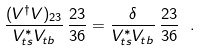Convert formula to latex. <formula><loc_0><loc_0><loc_500><loc_500>\frac { ( V ^ { \dagger } V ) _ { 2 3 } } { V _ { t s } ^ { * } V _ { t b } } \, \frac { 2 3 } { 3 6 } = \frac { \delta } { V _ { t s } ^ { * } V _ { t b } } \, \frac { 2 3 } { 3 6 } \ .</formula> 